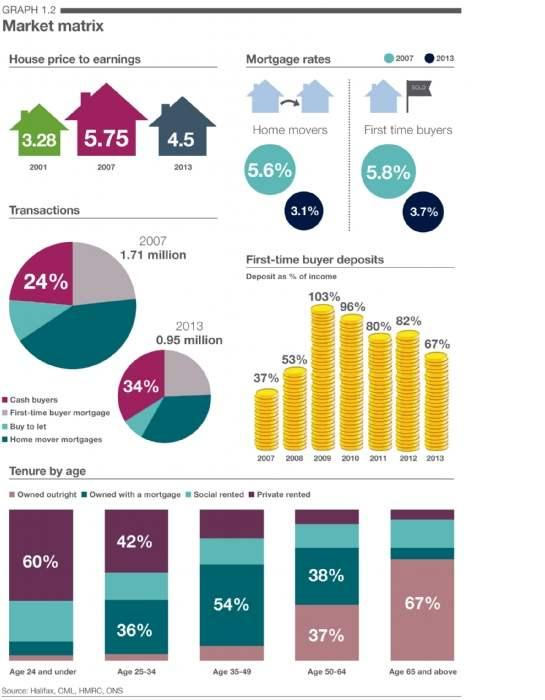Draw attention to some important aspects in this diagram. The mortgage home loan rate for first home buyers in 2013 was 3.7%. The mortgage home loan rate for first-time home buyers in 2007 was 5.8%. In the age group of 35-49, 54% of individuals have taken a mortgage home loan to purchase a home. The mortgage home loan rate for first-time buyers in 2007 was 2.1% higher than in 2013. As of 2007, the mortgage home loan rate for home movers was 5.6%. 